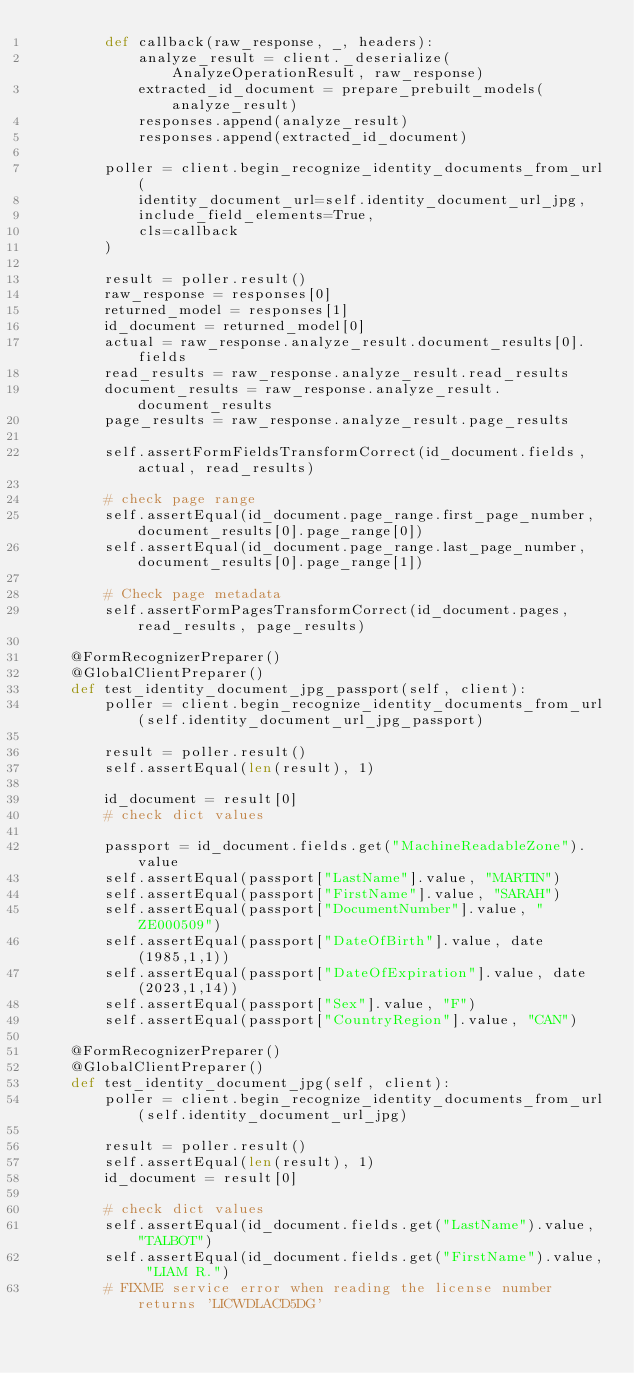<code> <loc_0><loc_0><loc_500><loc_500><_Python_>        def callback(raw_response, _, headers):
            analyze_result = client._deserialize(AnalyzeOperationResult, raw_response)
            extracted_id_document = prepare_prebuilt_models(analyze_result)
            responses.append(analyze_result)
            responses.append(extracted_id_document)

        poller = client.begin_recognize_identity_documents_from_url(
            identity_document_url=self.identity_document_url_jpg,
            include_field_elements=True,
            cls=callback
        )

        result = poller.result()
        raw_response = responses[0]
        returned_model = responses[1]
        id_document = returned_model[0]
        actual = raw_response.analyze_result.document_results[0].fields
        read_results = raw_response.analyze_result.read_results
        document_results = raw_response.analyze_result.document_results
        page_results = raw_response.analyze_result.page_results

        self.assertFormFieldsTransformCorrect(id_document.fields, actual, read_results)

        # check page range
        self.assertEqual(id_document.page_range.first_page_number, document_results[0].page_range[0])
        self.assertEqual(id_document.page_range.last_page_number, document_results[0].page_range[1])

        # Check page metadata
        self.assertFormPagesTransformCorrect(id_document.pages, read_results, page_results)

    @FormRecognizerPreparer()
    @GlobalClientPreparer()
    def test_identity_document_jpg_passport(self, client):
        poller = client.begin_recognize_identity_documents_from_url(self.identity_document_url_jpg_passport)

        result = poller.result()
        self.assertEqual(len(result), 1)
    
        id_document = result[0]
        # check dict values

        passport = id_document.fields.get("MachineReadableZone").value
        self.assertEqual(passport["LastName"].value, "MARTIN")
        self.assertEqual(passport["FirstName"].value, "SARAH")
        self.assertEqual(passport["DocumentNumber"].value, "ZE000509")
        self.assertEqual(passport["DateOfBirth"].value, date(1985,1,1))
        self.assertEqual(passport["DateOfExpiration"].value, date(2023,1,14))
        self.assertEqual(passport["Sex"].value, "F")
        self.assertEqual(passport["CountryRegion"].value, "CAN")

    @FormRecognizerPreparer()
    @GlobalClientPreparer()
    def test_identity_document_jpg(self, client):
        poller = client.begin_recognize_identity_documents_from_url(self.identity_document_url_jpg)

        result = poller.result()
        self.assertEqual(len(result), 1)
        id_document = result[0]

        # check dict values
        self.assertEqual(id_document.fields.get("LastName").value, "TALBOT")
        self.assertEqual(id_document.fields.get("FirstName").value, "LIAM R.")
        # FIXME service error when reading the license number returns 'LICWDLACD5DG'</code> 